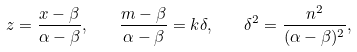<formula> <loc_0><loc_0><loc_500><loc_500>z = \frac { x - \beta } { \alpha - \beta } , \quad \frac { m - \beta } { \alpha - \beta } = k \delta , \quad \delta ^ { 2 } = \frac { n ^ { 2 } } { ( \alpha - \beta ) ^ { 2 } } ,</formula> 